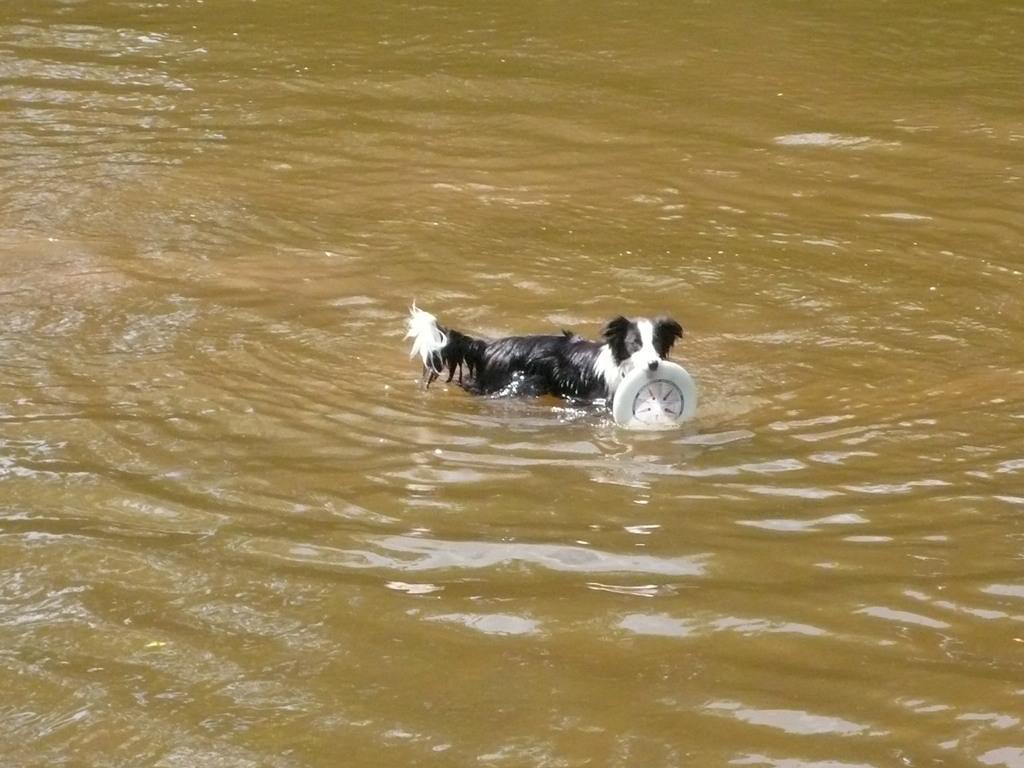What is present in the picture? There is water, a dog, and a white color flying disk in the picture. Can you describe the dog's position in the image? The dog is standing in the picture. What color is the dog? The dog is black and white in color. What is the dog holding in the image? The dog is holding a white color flying disk. Can you tell me how many firemen are present in the image? There are no firemen present in the image; it features a dog holding a flying disk near water. What type of bird can be seen flying in the image? There is no bird present in the image. 